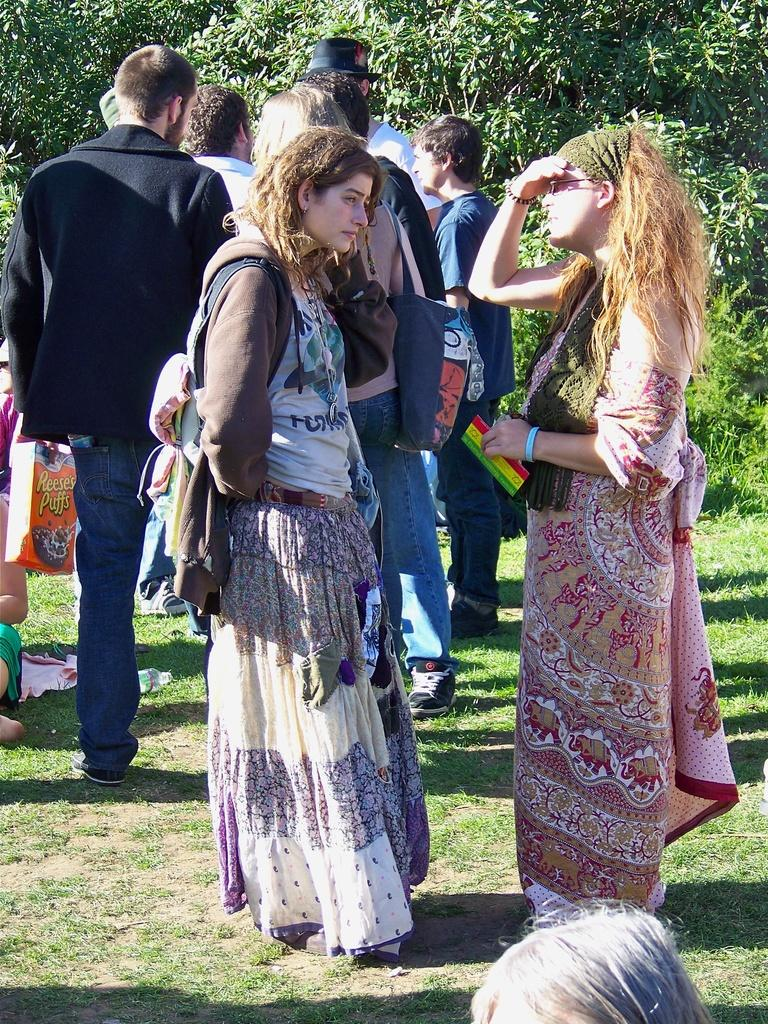What are the persons in the image doing? The persons in the image are standing on the ground and holding a paper and a box. What can be seen in the background of the image? There are trees and grass in the background of the image. What type of kite is being flown by the persons in the image? There is no kite present in the image; the persons are holding a paper and a box. Can you tell me how many toes are visible on the persons in the image? The image does not show the persons' toes, so it is not possible to determine how many are visible. 